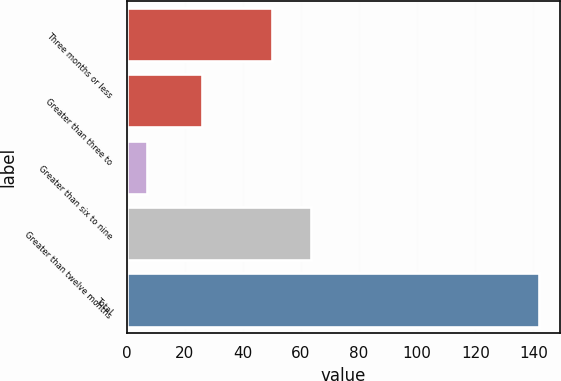Convert chart. <chart><loc_0><loc_0><loc_500><loc_500><bar_chart><fcel>Three months or less<fcel>Greater than three to<fcel>Greater than six to nine<fcel>Greater than twelve months<fcel>Total<nl><fcel>50<fcel>26<fcel>7<fcel>63.5<fcel>142<nl></chart> 